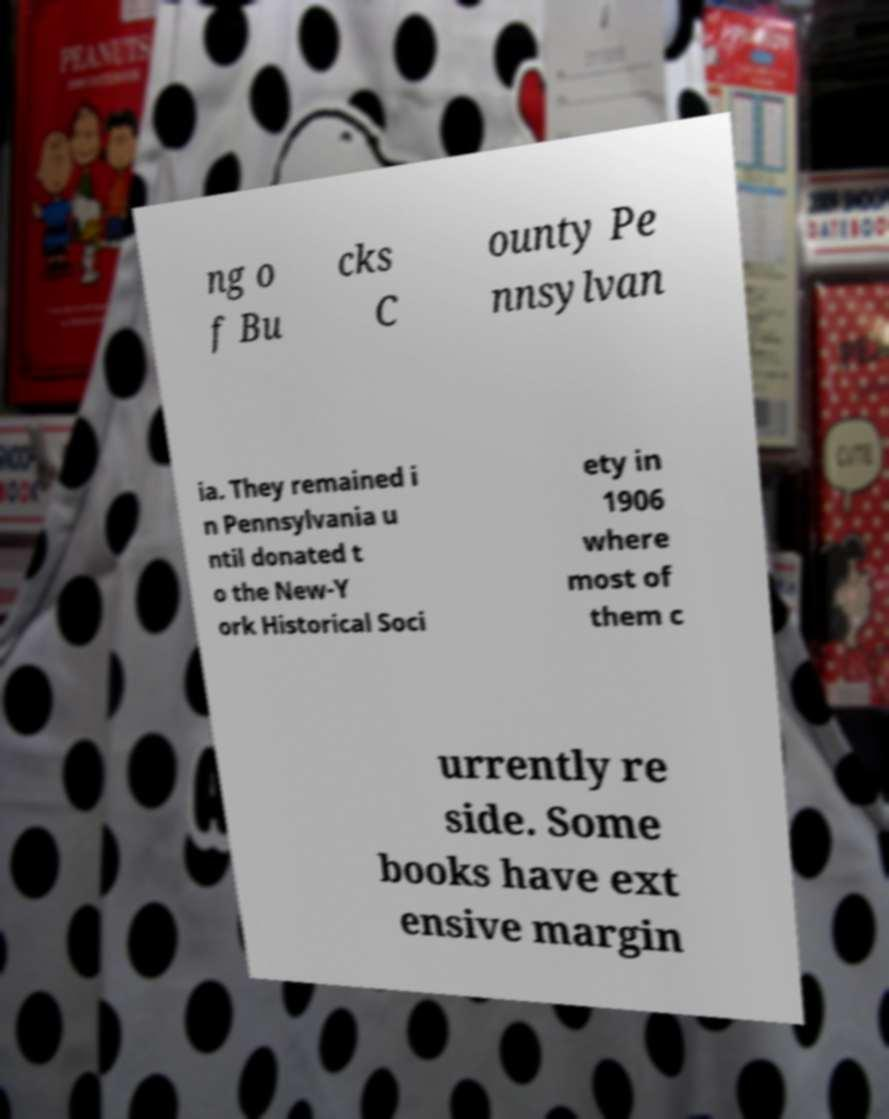Can you accurately transcribe the text from the provided image for me? ng o f Bu cks C ounty Pe nnsylvan ia. They remained i n Pennsylvania u ntil donated t o the New-Y ork Historical Soci ety in 1906 where most of them c urrently re side. Some books have ext ensive margin 